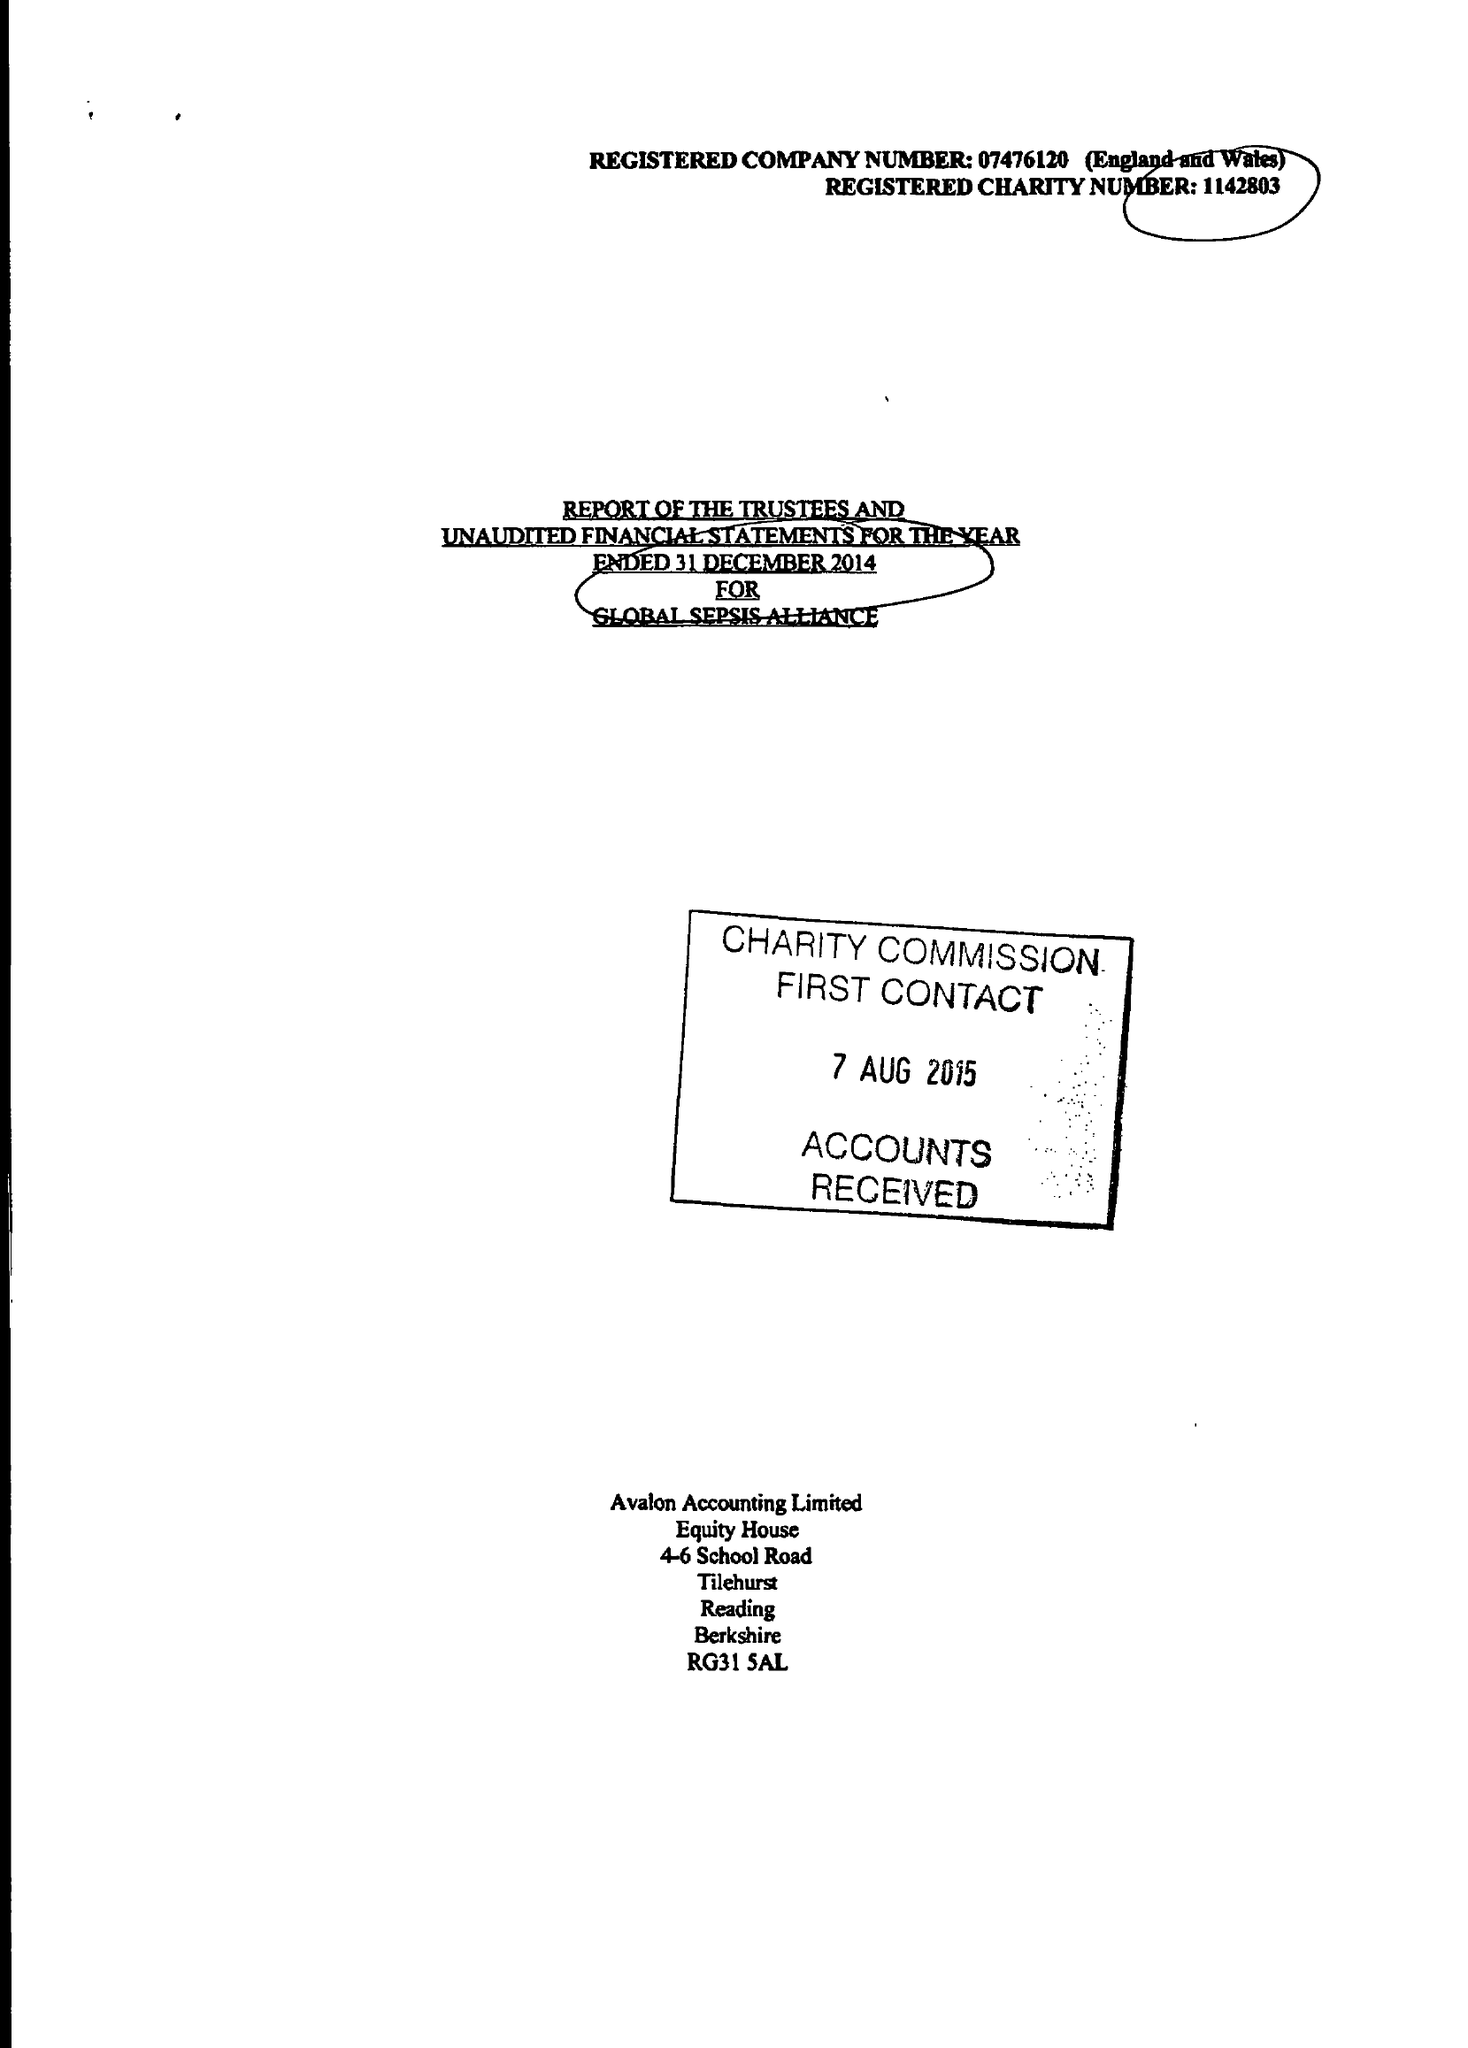What is the value for the address__street_line?
Answer the question using a single word or phrase. 2 LORDSWOOD 